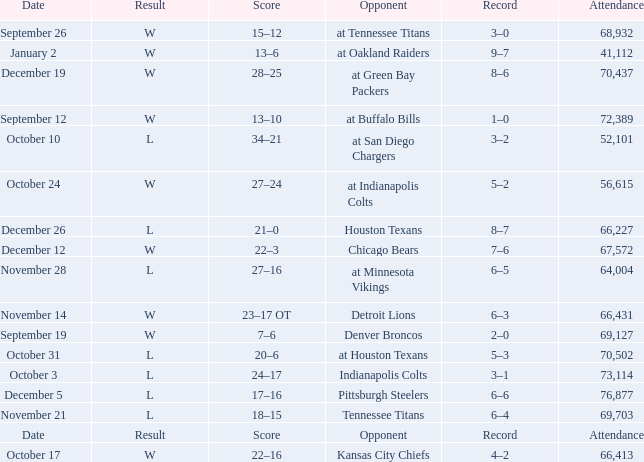What score has houston texans as the opponent? 21–0. 